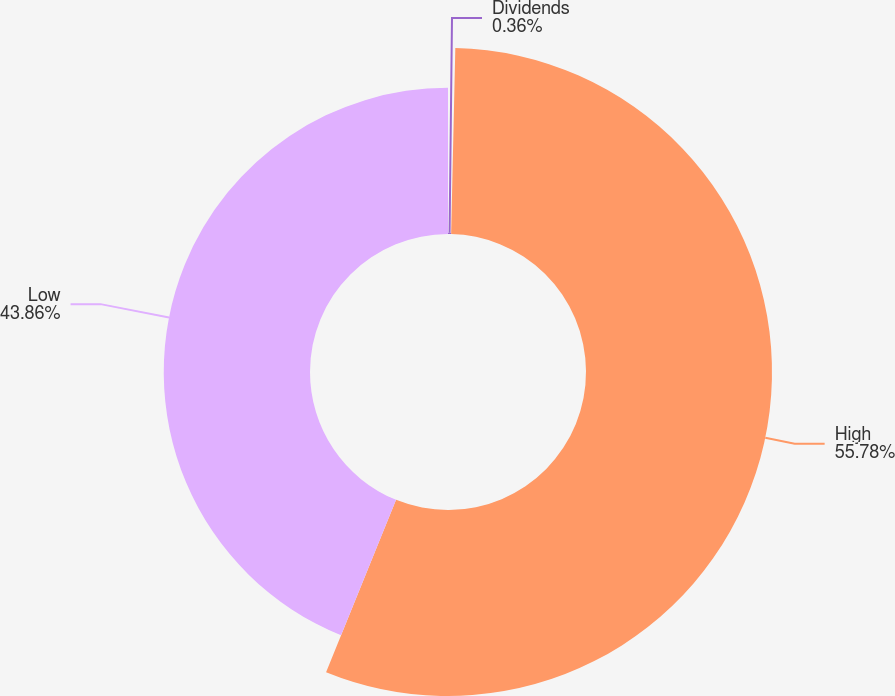Convert chart to OTSL. <chart><loc_0><loc_0><loc_500><loc_500><pie_chart><fcel>Dividends<fcel>High<fcel>Low<nl><fcel>0.36%<fcel>55.78%<fcel>43.86%<nl></chart> 